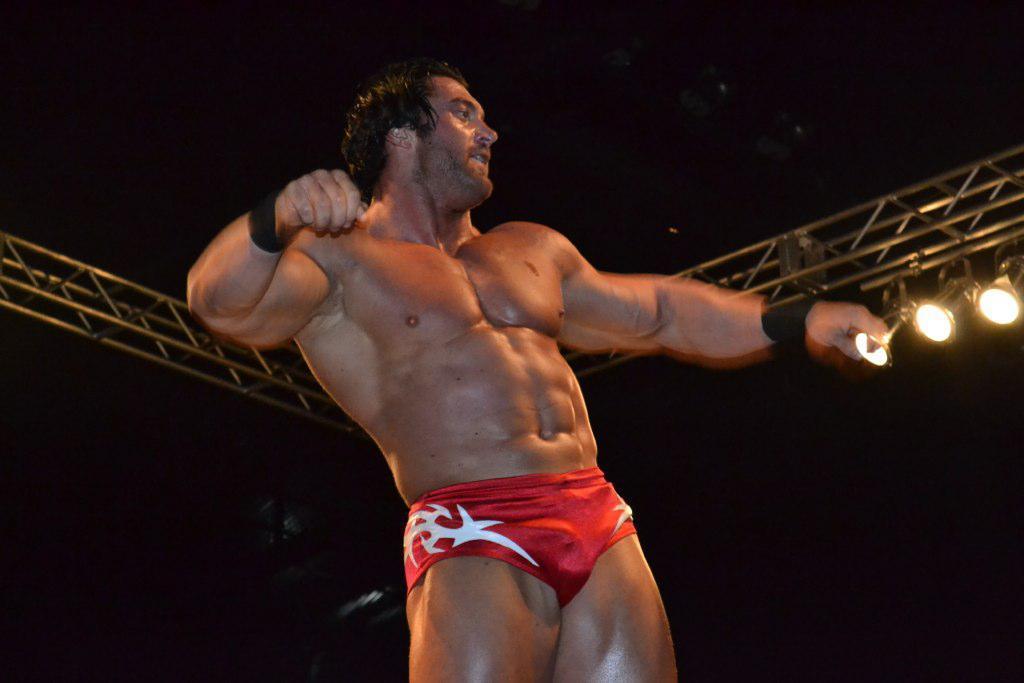Describe this image in one or two sentences. In this image I can see the person standing and wearing the red color dress. To the side I can see the metal rods many lights. And there is a black background. 